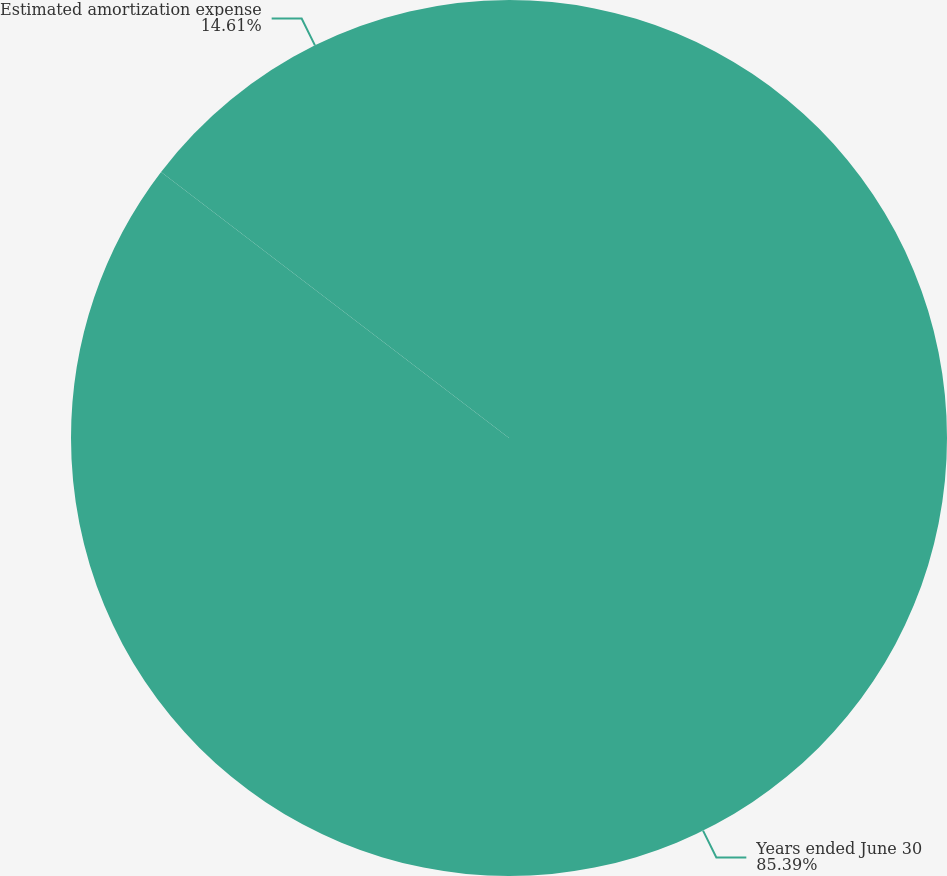Convert chart to OTSL. <chart><loc_0><loc_0><loc_500><loc_500><pie_chart><fcel>Years ended June 30<fcel>Estimated amortization expense<nl><fcel>85.39%<fcel>14.61%<nl></chart> 